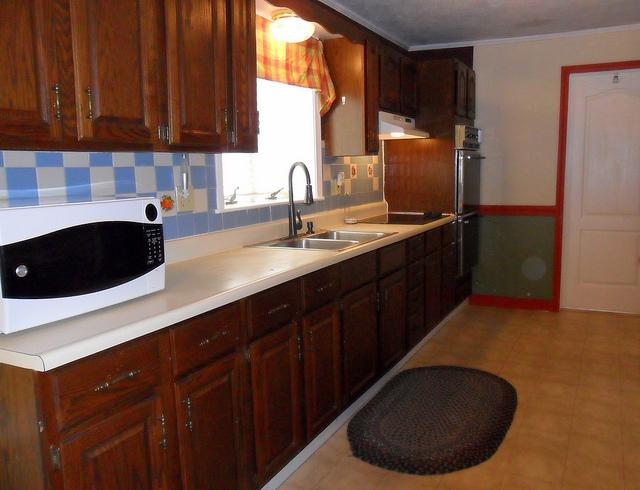What is the name for the pattern used on the window curtains?

Choices:
A) floral
B) plaid
C) birdseye
D) polka dot plaid 